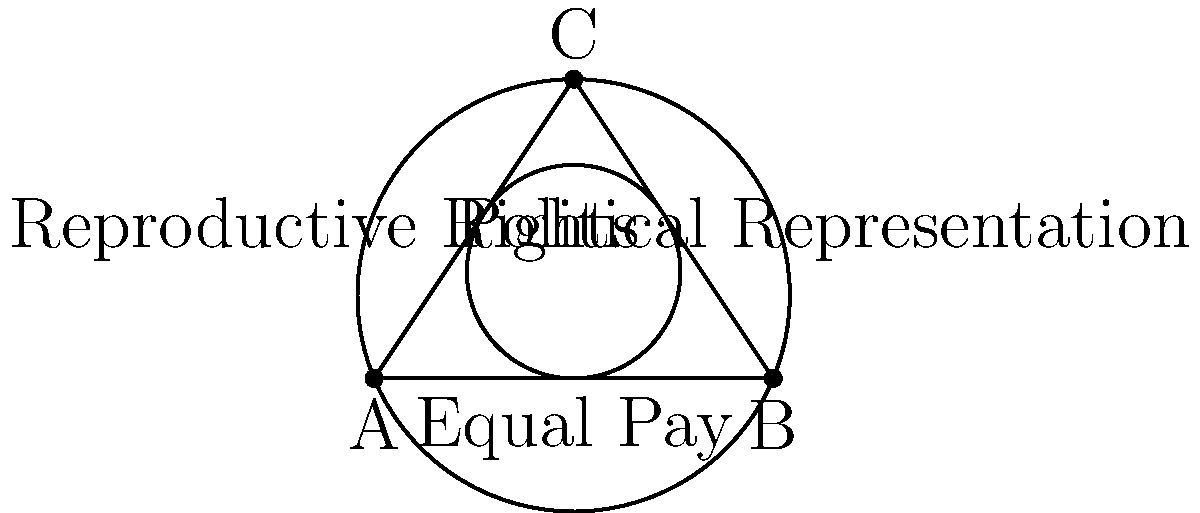In the triangle ABC, representing three key women's rights issues, an inscribed circle (representing policy focus) and a circumscribed circle (representing overall societal impact) are drawn. If the radius of the inscribed circle is $r$ and the radius of the circumscribed circle is $R$, what is the ratio of $\frac{r}{R}$ in terms of the semi-perimeter $s$ and the area $K$ of the triangle? To find the ratio of $\frac{r}{R}$, we'll use known formulas for the radii of inscribed and circumscribed circles in a triangle:

1) The radius of the inscribed circle is given by: $r = \frac{K}{s}$, where $K$ is the area of the triangle and $s$ is the semi-perimeter.

2) The radius of the circumscribed circle is given by: $R = \frac{abc}{4K}$, where $a$, $b$, and $c$ are the side lengths of the triangle.

3) We also know that $s = \frac{a+b+c}{2}$.

4) To find the ratio, we divide $r$ by $R$:

   $\frac{r}{R} = \frac{\frac{K}{s}}{\frac{abc}{4K}} = \frac{4K^2}{abcs}$

5) We can substitute $s = \frac{a+b+c}{2}$ into this equation:

   $\frac{r}{R} = \frac{4K^2}{abc(\frac{a+b+c}{2})} = \frac{8K^2}{abc(a+b+c)}$

This ratio represents the balance between focused policy efforts (inscribed circle) and broader societal impact (circumscribed circle) in addressing women's rights issues.
Answer: $$\frac{r}{R} = \frac{8K^2}{abc(a+b+c)}$$ 